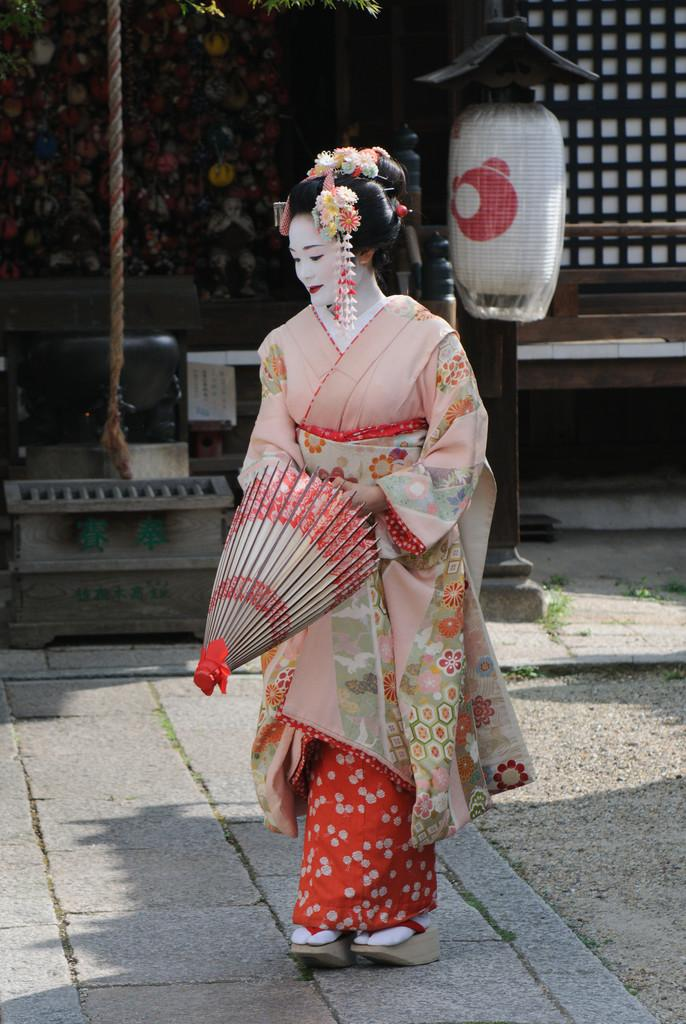Who is the main subject in the image? There is a woman in the center of the image. What is the woman doing in the image? The woman is standing on the floor and holding an umbrella. What can be seen in the background of the image? There is a light, a rope, a window, and a wall in the background of the image. What type of fruit is hanging from the rope in the image? There is no fruit hanging from the rope in the image; it is a light and a rope that can be seen in the background. What is the woman using to attach the umbrella to the wall in the image? There is no indication that the woman is attaching the umbrella to the wall in the image, and there is no glue or any other attachment method mentioned. 